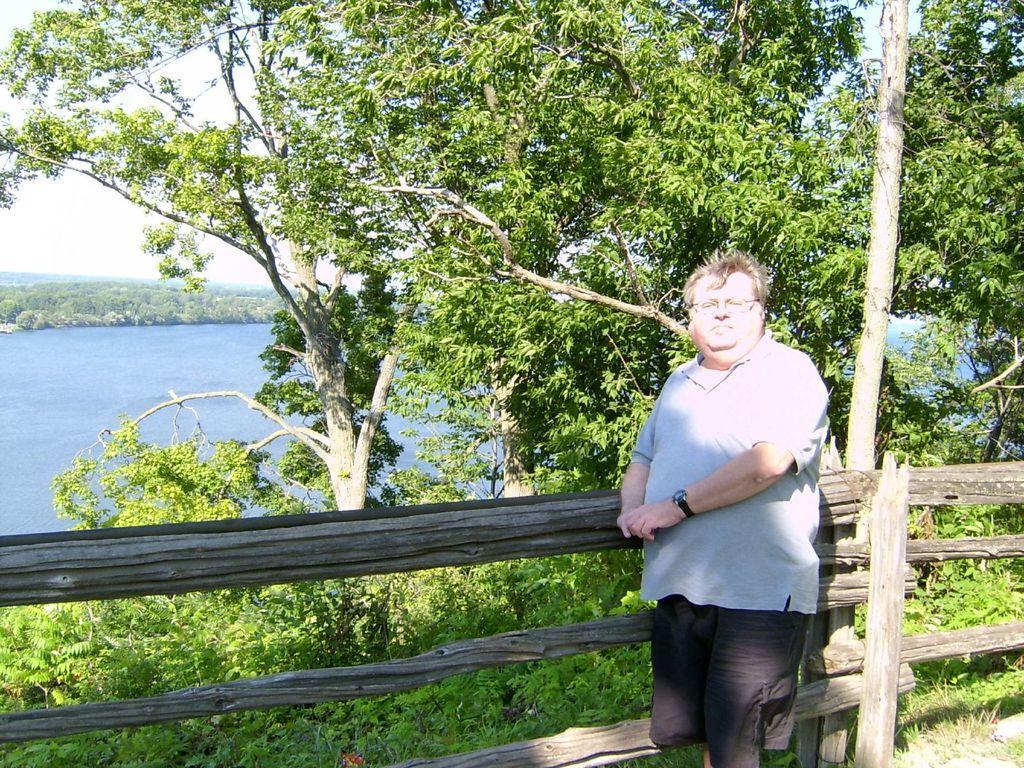Can you describe this image briefly? In the front of the image there is a person, wooden railing and trees. In the background of the image there is the sky, greenery and water. 